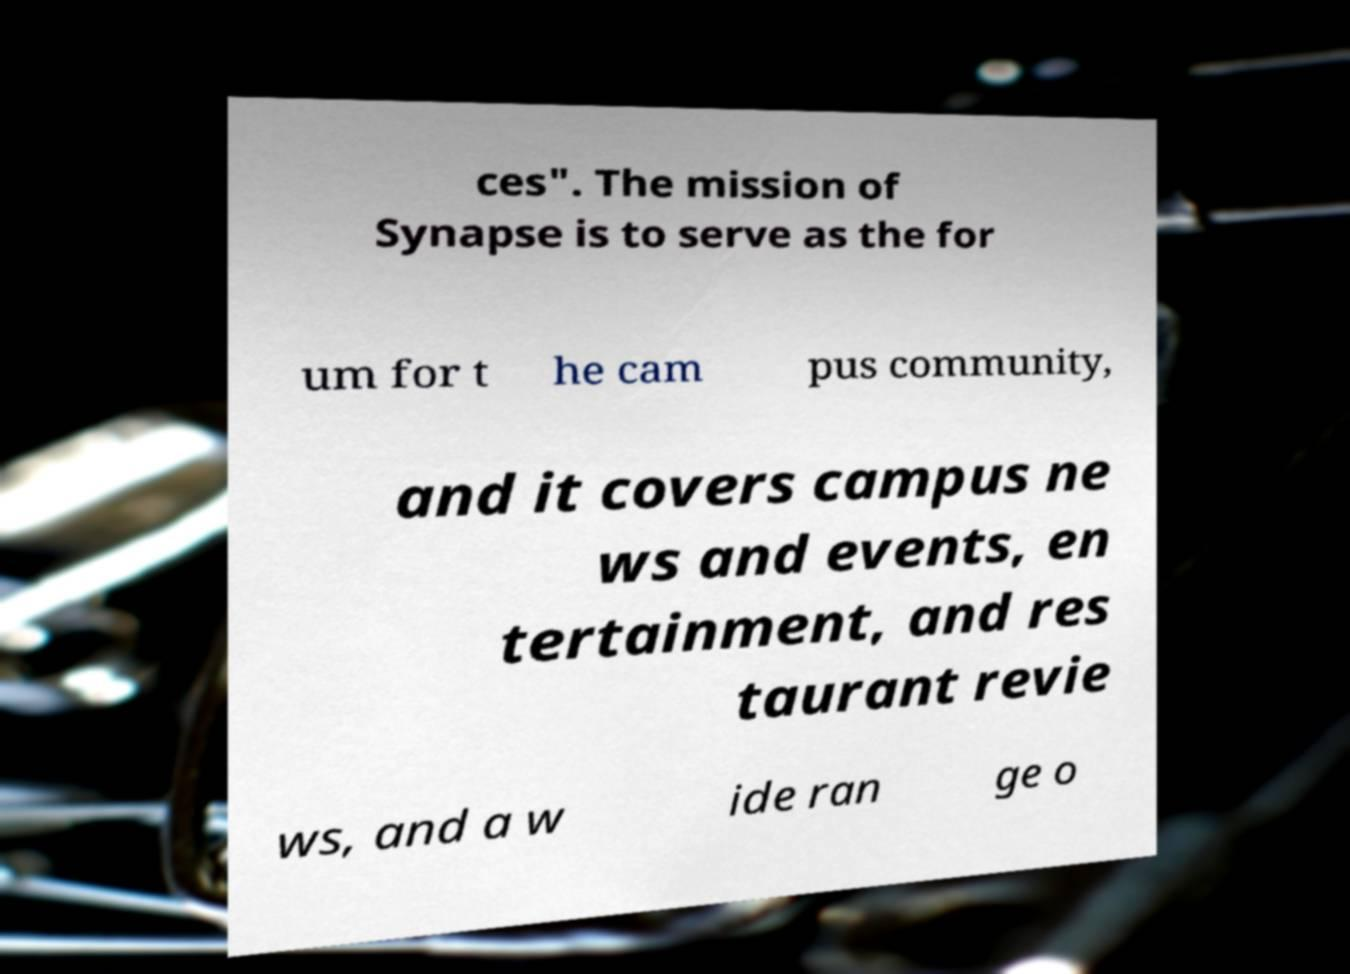There's text embedded in this image that I need extracted. Can you transcribe it verbatim? ces". The mission of Synapse is to serve as the for um for t he cam pus community, and it covers campus ne ws and events, en tertainment, and res taurant revie ws, and a w ide ran ge o 